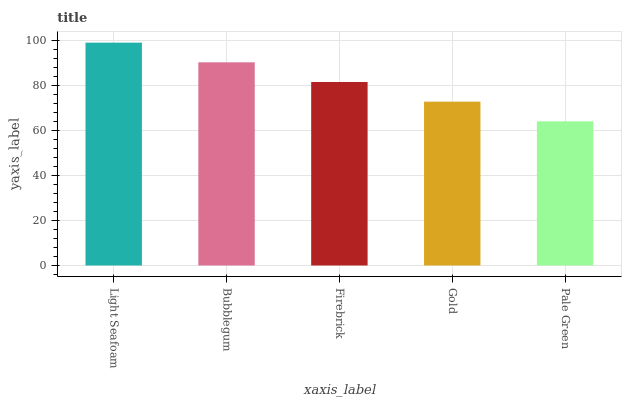Is Pale Green the minimum?
Answer yes or no. Yes. Is Light Seafoam the maximum?
Answer yes or no. Yes. Is Bubblegum the minimum?
Answer yes or no. No. Is Bubblegum the maximum?
Answer yes or no. No. Is Light Seafoam greater than Bubblegum?
Answer yes or no. Yes. Is Bubblegum less than Light Seafoam?
Answer yes or no. Yes. Is Bubblegum greater than Light Seafoam?
Answer yes or no. No. Is Light Seafoam less than Bubblegum?
Answer yes or no. No. Is Firebrick the high median?
Answer yes or no. Yes. Is Firebrick the low median?
Answer yes or no. Yes. Is Bubblegum the high median?
Answer yes or no. No. Is Bubblegum the low median?
Answer yes or no. No. 